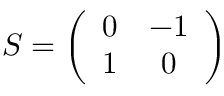<formula> <loc_0><loc_0><loc_500><loc_500>S = \left ( \begin{array} { c c } { 0 } & { - 1 } \\ { 1 } & { 0 } \end{array} \right )</formula> 